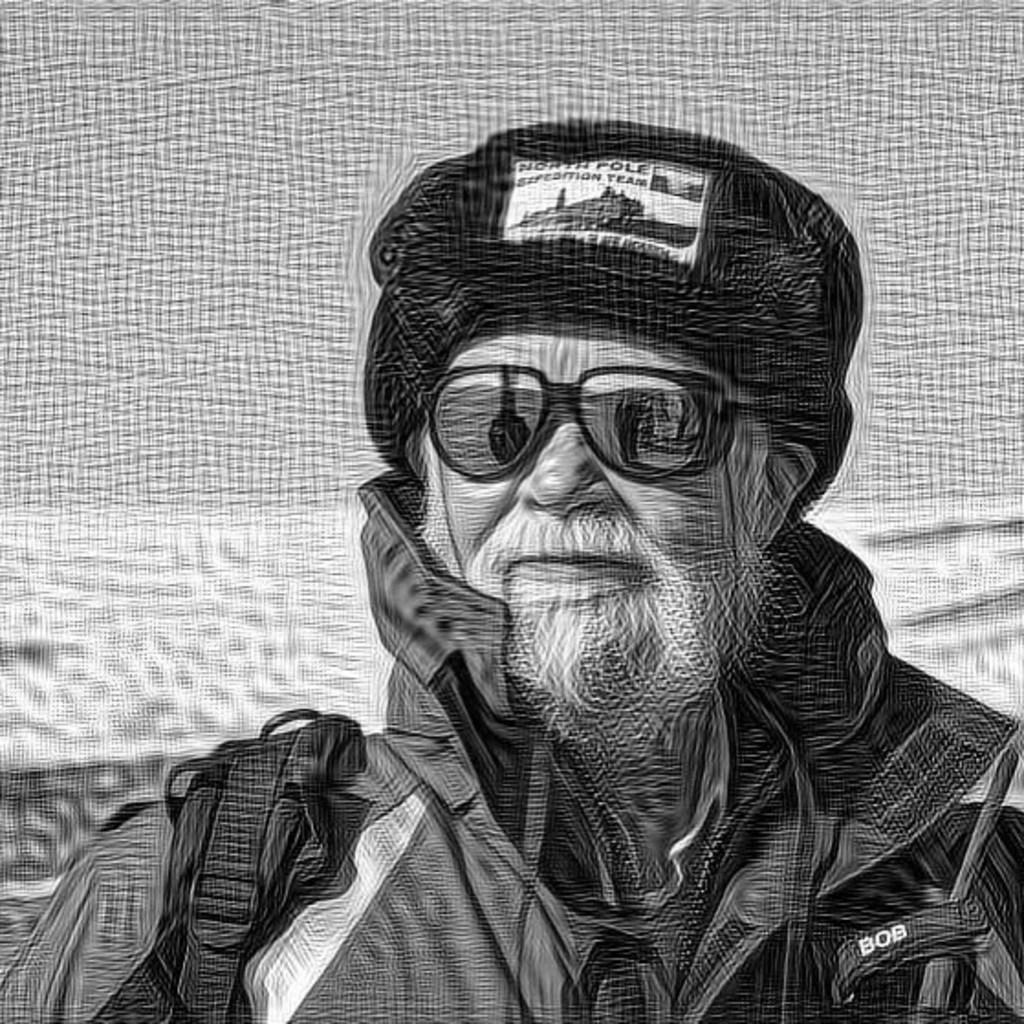What is the main subject of the painting? The painting depicts an old man. What is the old man wearing? The old man is wearing a jacket, a cap, and goggles. What is the old man carrying in the painting? The old man is carrying a bag. What can be observed about the old man's facial hair? The old man has a white beard and a white mustache. What type of horn can be seen on the old man's head in the painting? There is no horn present on the old man's head in the painting. Is the old man depicted in jail in the painting? There is no indication of a jail or any confinement in the painting; it simply depicts an old man. 